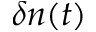Convert formula to latex. <formula><loc_0><loc_0><loc_500><loc_500>\delta n ( t )</formula> 